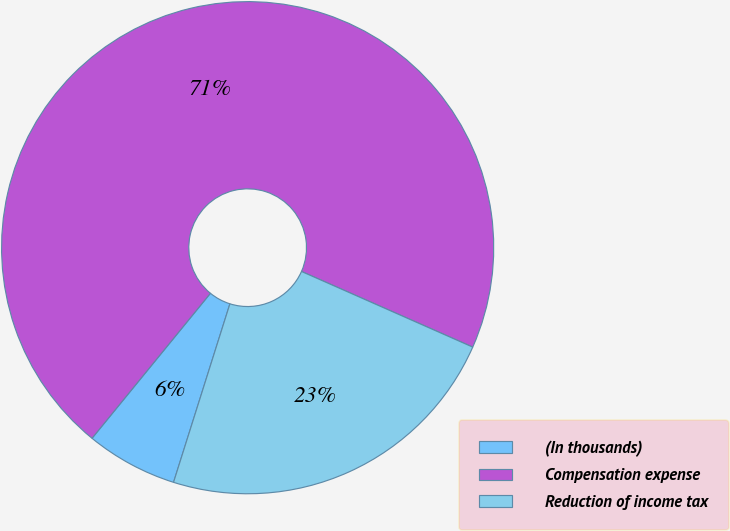Convert chart. <chart><loc_0><loc_0><loc_500><loc_500><pie_chart><fcel>(In thousands)<fcel>Compensation expense<fcel>Reduction of income tax<nl><fcel>6.03%<fcel>70.73%<fcel>23.25%<nl></chart> 